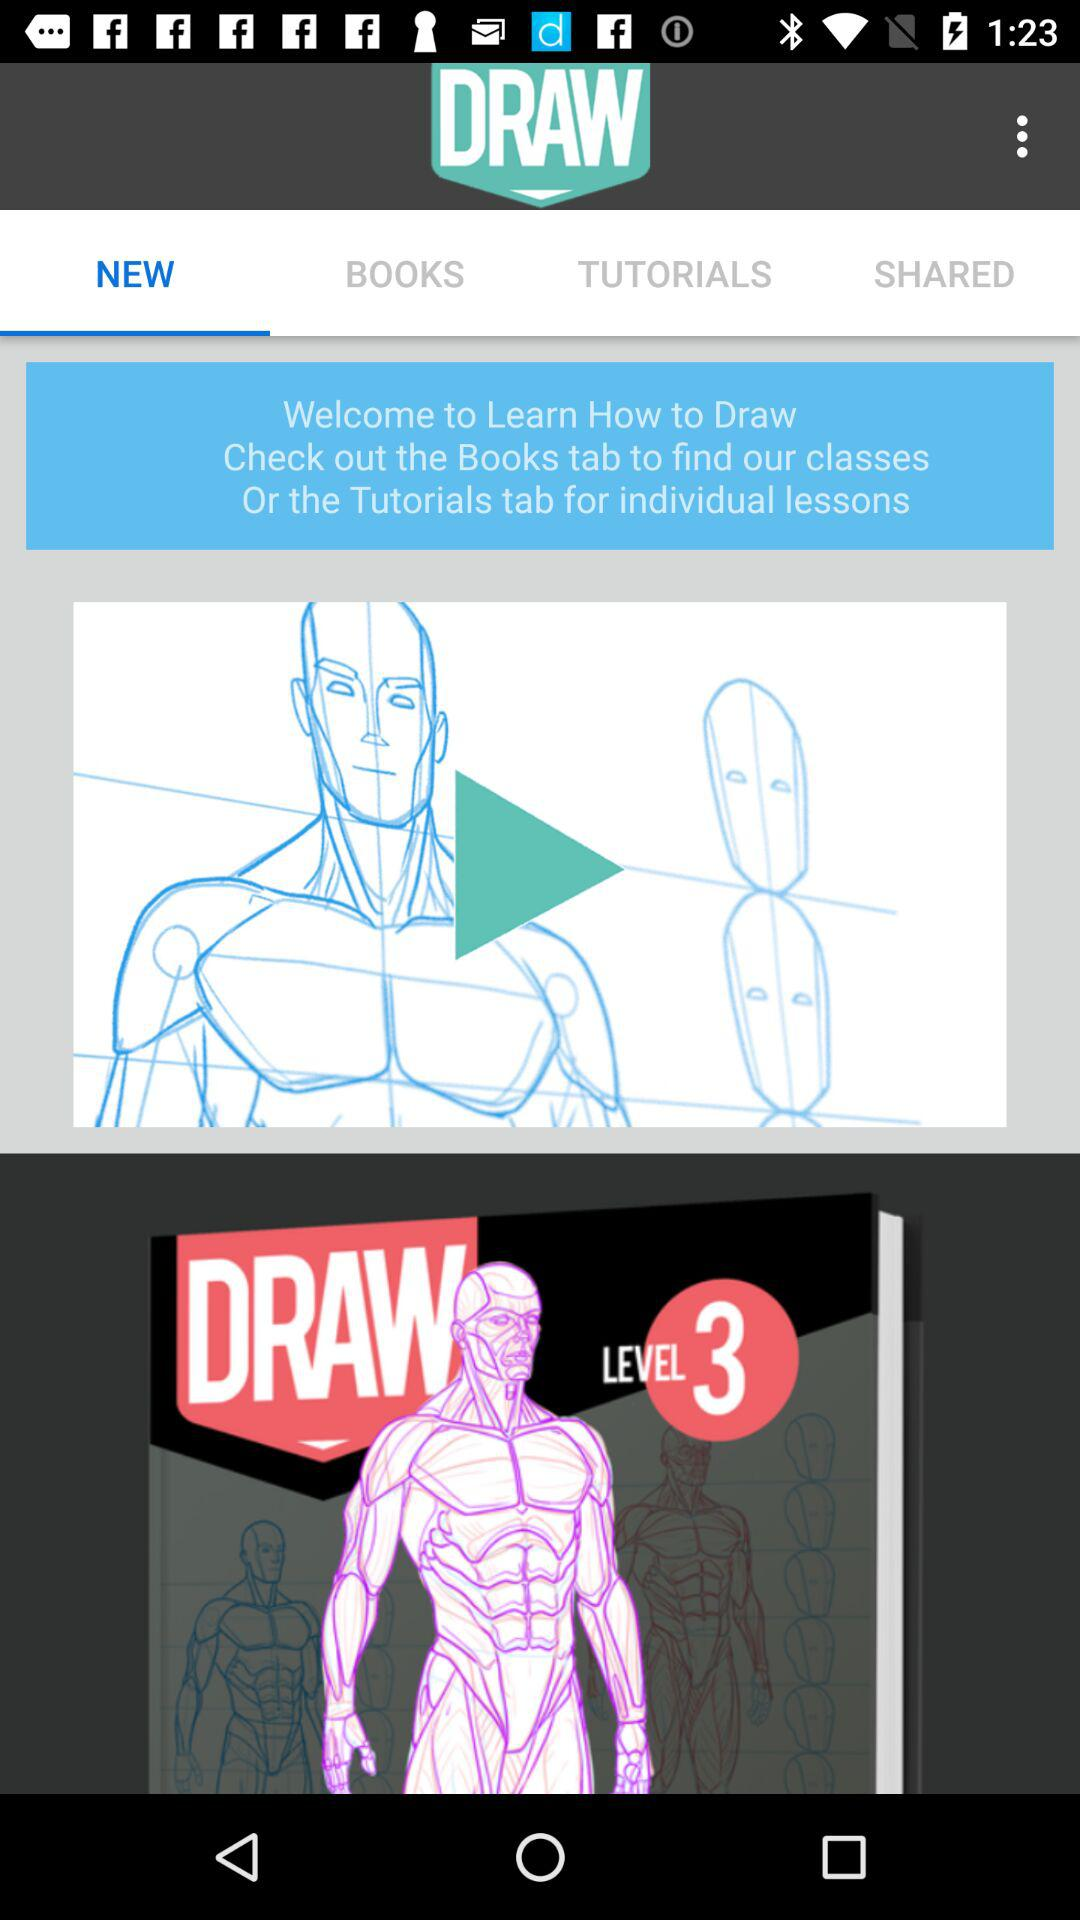How many levels are there in the Draw section?
Answer the question using a single word or phrase. 3 